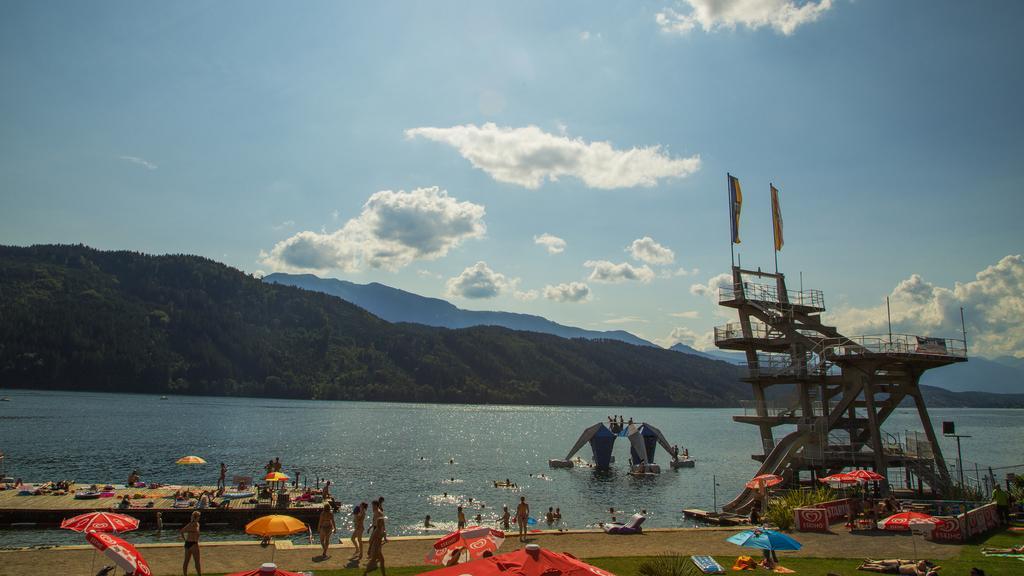Could you give a brief overview of what you see in this image? In this picture we can see some boats and some objects are in the water, around we can see some people, umbrellas and we can see hills. 